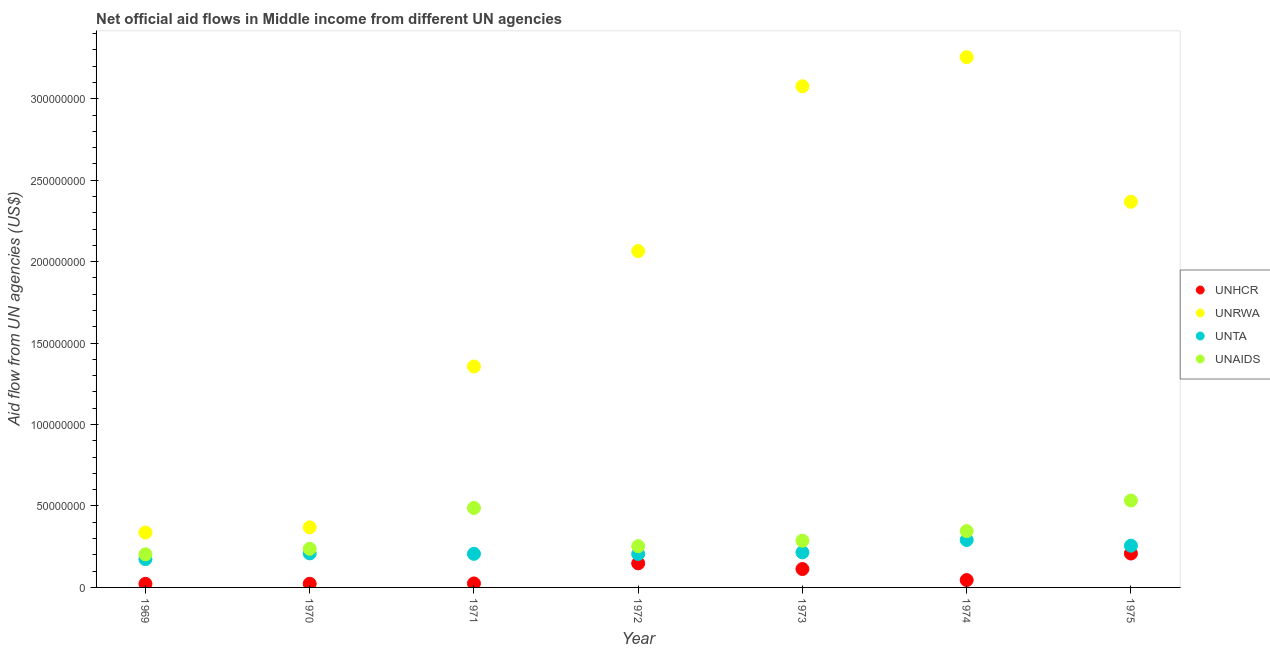What is the amount of aid given by unta in 1970?
Give a very brief answer. 2.09e+07. Across all years, what is the maximum amount of aid given by unrwa?
Your answer should be compact. 3.26e+08. Across all years, what is the minimum amount of aid given by unhcr?
Keep it short and to the point. 2.21e+06. In which year was the amount of aid given by unta maximum?
Keep it short and to the point. 1974. In which year was the amount of aid given by unaids minimum?
Keep it short and to the point. 1969. What is the total amount of aid given by unhcr in the graph?
Your answer should be very brief. 5.83e+07. What is the difference between the amount of aid given by unhcr in 1969 and that in 1970?
Keep it short and to the point. -3.00e+04. What is the difference between the amount of aid given by unaids in 1972 and the amount of aid given by unrwa in 1969?
Provide a short and direct response. -8.38e+06. What is the average amount of aid given by unhcr per year?
Your answer should be very brief. 8.33e+06. In the year 1970, what is the difference between the amount of aid given by unrwa and amount of aid given by unta?
Your answer should be compact. 1.60e+07. What is the ratio of the amount of aid given by unrwa in 1970 to that in 1972?
Your response must be concise. 0.18. What is the difference between the highest and the second highest amount of aid given by unrwa?
Give a very brief answer. 1.79e+07. What is the difference between the highest and the lowest amount of aid given by unta?
Make the answer very short. 1.18e+07. In how many years, is the amount of aid given by unta greater than the average amount of aid given by unta taken over all years?
Give a very brief answer. 2. Is the amount of aid given by unhcr strictly greater than the amount of aid given by unrwa over the years?
Keep it short and to the point. No. How many dotlines are there?
Offer a very short reply. 4. What is the difference between two consecutive major ticks on the Y-axis?
Your answer should be very brief. 5.00e+07. Are the values on the major ticks of Y-axis written in scientific E-notation?
Provide a short and direct response. No. Does the graph contain any zero values?
Ensure brevity in your answer.  No. Where does the legend appear in the graph?
Offer a very short reply. Center right. How are the legend labels stacked?
Your response must be concise. Vertical. What is the title of the graph?
Ensure brevity in your answer.  Net official aid flows in Middle income from different UN agencies. What is the label or title of the X-axis?
Ensure brevity in your answer.  Year. What is the label or title of the Y-axis?
Your answer should be very brief. Aid flow from UN agencies (US$). What is the Aid flow from UN agencies (US$) of UNHCR in 1969?
Your response must be concise. 2.21e+06. What is the Aid flow from UN agencies (US$) in UNRWA in 1969?
Offer a very short reply. 3.37e+07. What is the Aid flow from UN agencies (US$) of UNTA in 1969?
Provide a succinct answer. 1.74e+07. What is the Aid flow from UN agencies (US$) of UNAIDS in 1969?
Provide a short and direct response. 2.03e+07. What is the Aid flow from UN agencies (US$) in UNHCR in 1970?
Provide a succinct answer. 2.24e+06. What is the Aid flow from UN agencies (US$) of UNRWA in 1970?
Keep it short and to the point. 3.69e+07. What is the Aid flow from UN agencies (US$) of UNTA in 1970?
Your answer should be very brief. 2.09e+07. What is the Aid flow from UN agencies (US$) of UNAIDS in 1970?
Make the answer very short. 2.37e+07. What is the Aid flow from UN agencies (US$) of UNHCR in 1971?
Give a very brief answer. 2.44e+06. What is the Aid flow from UN agencies (US$) in UNRWA in 1971?
Keep it short and to the point. 1.36e+08. What is the Aid flow from UN agencies (US$) in UNTA in 1971?
Provide a succinct answer. 2.06e+07. What is the Aid flow from UN agencies (US$) of UNAIDS in 1971?
Your answer should be very brief. 4.88e+07. What is the Aid flow from UN agencies (US$) in UNHCR in 1972?
Provide a short and direct response. 1.48e+07. What is the Aid flow from UN agencies (US$) in UNRWA in 1972?
Offer a very short reply. 2.07e+08. What is the Aid flow from UN agencies (US$) in UNTA in 1972?
Your answer should be very brief. 2.05e+07. What is the Aid flow from UN agencies (US$) in UNAIDS in 1972?
Keep it short and to the point. 2.53e+07. What is the Aid flow from UN agencies (US$) of UNHCR in 1973?
Provide a succinct answer. 1.13e+07. What is the Aid flow from UN agencies (US$) of UNRWA in 1973?
Offer a terse response. 3.08e+08. What is the Aid flow from UN agencies (US$) in UNTA in 1973?
Give a very brief answer. 2.15e+07. What is the Aid flow from UN agencies (US$) in UNAIDS in 1973?
Ensure brevity in your answer.  2.87e+07. What is the Aid flow from UN agencies (US$) of UNHCR in 1974?
Make the answer very short. 4.51e+06. What is the Aid flow from UN agencies (US$) in UNRWA in 1974?
Your response must be concise. 3.26e+08. What is the Aid flow from UN agencies (US$) in UNTA in 1974?
Offer a very short reply. 2.91e+07. What is the Aid flow from UN agencies (US$) in UNAIDS in 1974?
Your answer should be compact. 3.46e+07. What is the Aid flow from UN agencies (US$) in UNHCR in 1975?
Offer a terse response. 2.08e+07. What is the Aid flow from UN agencies (US$) in UNRWA in 1975?
Your answer should be very brief. 2.37e+08. What is the Aid flow from UN agencies (US$) of UNTA in 1975?
Provide a succinct answer. 2.56e+07. What is the Aid flow from UN agencies (US$) in UNAIDS in 1975?
Offer a very short reply. 5.34e+07. Across all years, what is the maximum Aid flow from UN agencies (US$) of UNHCR?
Your response must be concise. 2.08e+07. Across all years, what is the maximum Aid flow from UN agencies (US$) in UNRWA?
Your answer should be very brief. 3.26e+08. Across all years, what is the maximum Aid flow from UN agencies (US$) in UNTA?
Your response must be concise. 2.91e+07. Across all years, what is the maximum Aid flow from UN agencies (US$) of UNAIDS?
Give a very brief answer. 5.34e+07. Across all years, what is the minimum Aid flow from UN agencies (US$) in UNHCR?
Provide a short and direct response. 2.21e+06. Across all years, what is the minimum Aid flow from UN agencies (US$) of UNRWA?
Provide a short and direct response. 3.37e+07. Across all years, what is the minimum Aid flow from UN agencies (US$) of UNTA?
Give a very brief answer. 1.74e+07. Across all years, what is the minimum Aid flow from UN agencies (US$) of UNAIDS?
Provide a succinct answer. 2.03e+07. What is the total Aid flow from UN agencies (US$) in UNHCR in the graph?
Provide a short and direct response. 5.83e+07. What is the total Aid flow from UN agencies (US$) in UNRWA in the graph?
Provide a succinct answer. 1.28e+09. What is the total Aid flow from UN agencies (US$) of UNTA in the graph?
Your answer should be very brief. 1.56e+08. What is the total Aid flow from UN agencies (US$) of UNAIDS in the graph?
Offer a very short reply. 2.35e+08. What is the difference between the Aid flow from UN agencies (US$) of UNHCR in 1969 and that in 1970?
Offer a terse response. -3.00e+04. What is the difference between the Aid flow from UN agencies (US$) of UNRWA in 1969 and that in 1970?
Ensure brevity in your answer.  -3.20e+06. What is the difference between the Aid flow from UN agencies (US$) in UNTA in 1969 and that in 1970?
Provide a short and direct response. -3.55e+06. What is the difference between the Aid flow from UN agencies (US$) in UNAIDS in 1969 and that in 1970?
Your response must be concise. -3.37e+06. What is the difference between the Aid flow from UN agencies (US$) of UNRWA in 1969 and that in 1971?
Give a very brief answer. -1.02e+08. What is the difference between the Aid flow from UN agencies (US$) of UNTA in 1969 and that in 1971?
Keep it short and to the point. -3.26e+06. What is the difference between the Aid flow from UN agencies (US$) in UNAIDS in 1969 and that in 1971?
Offer a terse response. -2.84e+07. What is the difference between the Aid flow from UN agencies (US$) of UNHCR in 1969 and that in 1972?
Give a very brief answer. -1.26e+07. What is the difference between the Aid flow from UN agencies (US$) of UNRWA in 1969 and that in 1972?
Keep it short and to the point. -1.73e+08. What is the difference between the Aid flow from UN agencies (US$) in UNTA in 1969 and that in 1972?
Ensure brevity in your answer.  -3.15e+06. What is the difference between the Aid flow from UN agencies (US$) of UNAIDS in 1969 and that in 1972?
Offer a very short reply. -4.99e+06. What is the difference between the Aid flow from UN agencies (US$) of UNHCR in 1969 and that in 1973?
Give a very brief answer. -9.09e+06. What is the difference between the Aid flow from UN agencies (US$) in UNRWA in 1969 and that in 1973?
Keep it short and to the point. -2.74e+08. What is the difference between the Aid flow from UN agencies (US$) of UNTA in 1969 and that in 1973?
Your answer should be very brief. -4.15e+06. What is the difference between the Aid flow from UN agencies (US$) in UNAIDS in 1969 and that in 1973?
Offer a terse response. -8.33e+06. What is the difference between the Aid flow from UN agencies (US$) in UNHCR in 1969 and that in 1974?
Ensure brevity in your answer.  -2.30e+06. What is the difference between the Aid flow from UN agencies (US$) of UNRWA in 1969 and that in 1974?
Your response must be concise. -2.92e+08. What is the difference between the Aid flow from UN agencies (US$) of UNTA in 1969 and that in 1974?
Provide a succinct answer. -1.18e+07. What is the difference between the Aid flow from UN agencies (US$) in UNAIDS in 1969 and that in 1974?
Your answer should be compact. -1.42e+07. What is the difference between the Aid flow from UN agencies (US$) in UNHCR in 1969 and that in 1975?
Your response must be concise. -1.86e+07. What is the difference between the Aid flow from UN agencies (US$) of UNRWA in 1969 and that in 1975?
Give a very brief answer. -2.03e+08. What is the difference between the Aid flow from UN agencies (US$) in UNTA in 1969 and that in 1975?
Your answer should be compact. -8.25e+06. What is the difference between the Aid flow from UN agencies (US$) of UNAIDS in 1969 and that in 1975?
Give a very brief answer. -3.30e+07. What is the difference between the Aid flow from UN agencies (US$) of UNRWA in 1970 and that in 1971?
Offer a very short reply. -9.87e+07. What is the difference between the Aid flow from UN agencies (US$) in UNTA in 1970 and that in 1971?
Provide a short and direct response. 2.90e+05. What is the difference between the Aid flow from UN agencies (US$) in UNAIDS in 1970 and that in 1971?
Offer a very short reply. -2.51e+07. What is the difference between the Aid flow from UN agencies (US$) in UNHCR in 1970 and that in 1972?
Make the answer very short. -1.26e+07. What is the difference between the Aid flow from UN agencies (US$) in UNRWA in 1970 and that in 1972?
Offer a very short reply. -1.70e+08. What is the difference between the Aid flow from UN agencies (US$) of UNTA in 1970 and that in 1972?
Make the answer very short. 4.00e+05. What is the difference between the Aid flow from UN agencies (US$) in UNAIDS in 1970 and that in 1972?
Keep it short and to the point. -1.62e+06. What is the difference between the Aid flow from UN agencies (US$) of UNHCR in 1970 and that in 1973?
Ensure brevity in your answer.  -9.06e+06. What is the difference between the Aid flow from UN agencies (US$) in UNRWA in 1970 and that in 1973?
Your answer should be very brief. -2.71e+08. What is the difference between the Aid flow from UN agencies (US$) in UNTA in 1970 and that in 1973?
Your response must be concise. -6.00e+05. What is the difference between the Aid flow from UN agencies (US$) in UNAIDS in 1970 and that in 1973?
Your response must be concise. -4.96e+06. What is the difference between the Aid flow from UN agencies (US$) in UNHCR in 1970 and that in 1974?
Offer a very short reply. -2.27e+06. What is the difference between the Aid flow from UN agencies (US$) in UNRWA in 1970 and that in 1974?
Ensure brevity in your answer.  -2.89e+08. What is the difference between the Aid flow from UN agencies (US$) in UNTA in 1970 and that in 1974?
Offer a terse response. -8.21e+06. What is the difference between the Aid flow from UN agencies (US$) in UNAIDS in 1970 and that in 1974?
Ensure brevity in your answer.  -1.09e+07. What is the difference between the Aid flow from UN agencies (US$) of UNHCR in 1970 and that in 1975?
Provide a succinct answer. -1.86e+07. What is the difference between the Aid flow from UN agencies (US$) of UNRWA in 1970 and that in 1975?
Your answer should be very brief. -2.00e+08. What is the difference between the Aid flow from UN agencies (US$) in UNTA in 1970 and that in 1975?
Offer a terse response. -4.70e+06. What is the difference between the Aid flow from UN agencies (US$) in UNAIDS in 1970 and that in 1975?
Keep it short and to the point. -2.97e+07. What is the difference between the Aid flow from UN agencies (US$) of UNHCR in 1971 and that in 1972?
Provide a short and direct response. -1.24e+07. What is the difference between the Aid flow from UN agencies (US$) in UNRWA in 1971 and that in 1972?
Offer a very short reply. -7.09e+07. What is the difference between the Aid flow from UN agencies (US$) in UNAIDS in 1971 and that in 1972?
Ensure brevity in your answer.  2.35e+07. What is the difference between the Aid flow from UN agencies (US$) of UNHCR in 1971 and that in 1973?
Provide a succinct answer. -8.86e+06. What is the difference between the Aid flow from UN agencies (US$) in UNRWA in 1971 and that in 1973?
Your response must be concise. -1.72e+08. What is the difference between the Aid flow from UN agencies (US$) of UNTA in 1971 and that in 1973?
Ensure brevity in your answer.  -8.90e+05. What is the difference between the Aid flow from UN agencies (US$) of UNAIDS in 1971 and that in 1973?
Your answer should be compact. 2.01e+07. What is the difference between the Aid flow from UN agencies (US$) in UNHCR in 1971 and that in 1974?
Ensure brevity in your answer.  -2.07e+06. What is the difference between the Aid flow from UN agencies (US$) in UNRWA in 1971 and that in 1974?
Provide a short and direct response. -1.90e+08. What is the difference between the Aid flow from UN agencies (US$) in UNTA in 1971 and that in 1974?
Provide a succinct answer. -8.50e+06. What is the difference between the Aid flow from UN agencies (US$) of UNAIDS in 1971 and that in 1974?
Provide a short and direct response. 1.42e+07. What is the difference between the Aid flow from UN agencies (US$) of UNHCR in 1971 and that in 1975?
Provide a short and direct response. -1.84e+07. What is the difference between the Aid flow from UN agencies (US$) of UNRWA in 1971 and that in 1975?
Offer a very short reply. -1.01e+08. What is the difference between the Aid flow from UN agencies (US$) in UNTA in 1971 and that in 1975?
Provide a succinct answer. -4.99e+06. What is the difference between the Aid flow from UN agencies (US$) in UNAIDS in 1971 and that in 1975?
Keep it short and to the point. -4.58e+06. What is the difference between the Aid flow from UN agencies (US$) of UNHCR in 1972 and that in 1973?
Keep it short and to the point. 3.49e+06. What is the difference between the Aid flow from UN agencies (US$) of UNRWA in 1972 and that in 1973?
Ensure brevity in your answer.  -1.01e+08. What is the difference between the Aid flow from UN agencies (US$) of UNTA in 1972 and that in 1973?
Your answer should be compact. -1.00e+06. What is the difference between the Aid flow from UN agencies (US$) in UNAIDS in 1972 and that in 1973?
Your response must be concise. -3.34e+06. What is the difference between the Aid flow from UN agencies (US$) of UNHCR in 1972 and that in 1974?
Your response must be concise. 1.03e+07. What is the difference between the Aid flow from UN agencies (US$) of UNRWA in 1972 and that in 1974?
Offer a terse response. -1.19e+08. What is the difference between the Aid flow from UN agencies (US$) in UNTA in 1972 and that in 1974?
Offer a very short reply. -8.61e+06. What is the difference between the Aid flow from UN agencies (US$) in UNAIDS in 1972 and that in 1974?
Offer a terse response. -9.25e+06. What is the difference between the Aid flow from UN agencies (US$) of UNHCR in 1972 and that in 1975?
Your answer should be very brief. -6.03e+06. What is the difference between the Aid flow from UN agencies (US$) of UNRWA in 1972 and that in 1975?
Give a very brief answer. -3.03e+07. What is the difference between the Aid flow from UN agencies (US$) in UNTA in 1972 and that in 1975?
Give a very brief answer. -5.10e+06. What is the difference between the Aid flow from UN agencies (US$) in UNAIDS in 1972 and that in 1975?
Provide a short and direct response. -2.80e+07. What is the difference between the Aid flow from UN agencies (US$) of UNHCR in 1973 and that in 1974?
Offer a very short reply. 6.79e+06. What is the difference between the Aid flow from UN agencies (US$) in UNRWA in 1973 and that in 1974?
Give a very brief answer. -1.79e+07. What is the difference between the Aid flow from UN agencies (US$) of UNTA in 1973 and that in 1974?
Give a very brief answer. -7.61e+06. What is the difference between the Aid flow from UN agencies (US$) of UNAIDS in 1973 and that in 1974?
Keep it short and to the point. -5.91e+06. What is the difference between the Aid flow from UN agencies (US$) of UNHCR in 1973 and that in 1975?
Offer a very short reply. -9.52e+06. What is the difference between the Aid flow from UN agencies (US$) of UNRWA in 1973 and that in 1975?
Provide a short and direct response. 7.09e+07. What is the difference between the Aid flow from UN agencies (US$) in UNTA in 1973 and that in 1975?
Your answer should be compact. -4.10e+06. What is the difference between the Aid flow from UN agencies (US$) in UNAIDS in 1973 and that in 1975?
Offer a very short reply. -2.47e+07. What is the difference between the Aid flow from UN agencies (US$) in UNHCR in 1974 and that in 1975?
Make the answer very short. -1.63e+07. What is the difference between the Aid flow from UN agencies (US$) of UNRWA in 1974 and that in 1975?
Make the answer very short. 8.88e+07. What is the difference between the Aid flow from UN agencies (US$) in UNTA in 1974 and that in 1975?
Keep it short and to the point. 3.51e+06. What is the difference between the Aid flow from UN agencies (US$) of UNAIDS in 1974 and that in 1975?
Keep it short and to the point. -1.88e+07. What is the difference between the Aid flow from UN agencies (US$) in UNHCR in 1969 and the Aid flow from UN agencies (US$) in UNRWA in 1970?
Your answer should be compact. -3.47e+07. What is the difference between the Aid flow from UN agencies (US$) in UNHCR in 1969 and the Aid flow from UN agencies (US$) in UNTA in 1970?
Give a very brief answer. -1.87e+07. What is the difference between the Aid flow from UN agencies (US$) in UNHCR in 1969 and the Aid flow from UN agencies (US$) in UNAIDS in 1970?
Make the answer very short. -2.15e+07. What is the difference between the Aid flow from UN agencies (US$) of UNRWA in 1969 and the Aid flow from UN agencies (US$) of UNTA in 1970?
Your response must be concise. 1.28e+07. What is the difference between the Aid flow from UN agencies (US$) in UNTA in 1969 and the Aid flow from UN agencies (US$) in UNAIDS in 1970?
Your answer should be very brief. -6.33e+06. What is the difference between the Aid flow from UN agencies (US$) of UNHCR in 1969 and the Aid flow from UN agencies (US$) of UNRWA in 1971?
Provide a succinct answer. -1.33e+08. What is the difference between the Aid flow from UN agencies (US$) in UNHCR in 1969 and the Aid flow from UN agencies (US$) in UNTA in 1971?
Your answer should be very brief. -1.84e+07. What is the difference between the Aid flow from UN agencies (US$) in UNHCR in 1969 and the Aid flow from UN agencies (US$) in UNAIDS in 1971?
Provide a succinct answer. -4.66e+07. What is the difference between the Aid flow from UN agencies (US$) in UNRWA in 1969 and the Aid flow from UN agencies (US$) in UNTA in 1971?
Your answer should be very brief. 1.31e+07. What is the difference between the Aid flow from UN agencies (US$) of UNRWA in 1969 and the Aid flow from UN agencies (US$) of UNAIDS in 1971?
Your response must be concise. -1.51e+07. What is the difference between the Aid flow from UN agencies (US$) in UNTA in 1969 and the Aid flow from UN agencies (US$) in UNAIDS in 1971?
Make the answer very short. -3.14e+07. What is the difference between the Aid flow from UN agencies (US$) in UNHCR in 1969 and the Aid flow from UN agencies (US$) in UNRWA in 1972?
Ensure brevity in your answer.  -2.04e+08. What is the difference between the Aid flow from UN agencies (US$) in UNHCR in 1969 and the Aid flow from UN agencies (US$) in UNTA in 1972?
Offer a very short reply. -1.83e+07. What is the difference between the Aid flow from UN agencies (US$) of UNHCR in 1969 and the Aid flow from UN agencies (US$) of UNAIDS in 1972?
Your answer should be very brief. -2.31e+07. What is the difference between the Aid flow from UN agencies (US$) of UNRWA in 1969 and the Aid flow from UN agencies (US$) of UNTA in 1972?
Your response must be concise. 1.32e+07. What is the difference between the Aid flow from UN agencies (US$) in UNRWA in 1969 and the Aid flow from UN agencies (US$) in UNAIDS in 1972?
Keep it short and to the point. 8.38e+06. What is the difference between the Aid flow from UN agencies (US$) in UNTA in 1969 and the Aid flow from UN agencies (US$) in UNAIDS in 1972?
Give a very brief answer. -7.95e+06. What is the difference between the Aid flow from UN agencies (US$) in UNHCR in 1969 and the Aid flow from UN agencies (US$) in UNRWA in 1973?
Offer a very short reply. -3.05e+08. What is the difference between the Aid flow from UN agencies (US$) of UNHCR in 1969 and the Aid flow from UN agencies (US$) of UNTA in 1973?
Offer a terse response. -1.93e+07. What is the difference between the Aid flow from UN agencies (US$) in UNHCR in 1969 and the Aid flow from UN agencies (US$) in UNAIDS in 1973?
Ensure brevity in your answer.  -2.64e+07. What is the difference between the Aid flow from UN agencies (US$) of UNRWA in 1969 and the Aid flow from UN agencies (US$) of UNTA in 1973?
Provide a short and direct response. 1.22e+07. What is the difference between the Aid flow from UN agencies (US$) of UNRWA in 1969 and the Aid flow from UN agencies (US$) of UNAIDS in 1973?
Offer a very short reply. 5.04e+06. What is the difference between the Aid flow from UN agencies (US$) of UNTA in 1969 and the Aid flow from UN agencies (US$) of UNAIDS in 1973?
Provide a short and direct response. -1.13e+07. What is the difference between the Aid flow from UN agencies (US$) in UNHCR in 1969 and the Aid flow from UN agencies (US$) in UNRWA in 1974?
Offer a terse response. -3.23e+08. What is the difference between the Aid flow from UN agencies (US$) in UNHCR in 1969 and the Aid flow from UN agencies (US$) in UNTA in 1974?
Make the answer very short. -2.69e+07. What is the difference between the Aid flow from UN agencies (US$) of UNHCR in 1969 and the Aid flow from UN agencies (US$) of UNAIDS in 1974?
Offer a terse response. -3.24e+07. What is the difference between the Aid flow from UN agencies (US$) in UNRWA in 1969 and the Aid flow from UN agencies (US$) in UNTA in 1974?
Make the answer very short. 4.57e+06. What is the difference between the Aid flow from UN agencies (US$) in UNRWA in 1969 and the Aid flow from UN agencies (US$) in UNAIDS in 1974?
Give a very brief answer. -8.70e+05. What is the difference between the Aid flow from UN agencies (US$) in UNTA in 1969 and the Aid flow from UN agencies (US$) in UNAIDS in 1974?
Ensure brevity in your answer.  -1.72e+07. What is the difference between the Aid flow from UN agencies (US$) of UNHCR in 1969 and the Aid flow from UN agencies (US$) of UNRWA in 1975?
Provide a short and direct response. -2.35e+08. What is the difference between the Aid flow from UN agencies (US$) in UNHCR in 1969 and the Aid flow from UN agencies (US$) in UNTA in 1975?
Make the answer very short. -2.34e+07. What is the difference between the Aid flow from UN agencies (US$) in UNHCR in 1969 and the Aid flow from UN agencies (US$) in UNAIDS in 1975?
Offer a very short reply. -5.12e+07. What is the difference between the Aid flow from UN agencies (US$) in UNRWA in 1969 and the Aid flow from UN agencies (US$) in UNTA in 1975?
Offer a terse response. 8.08e+06. What is the difference between the Aid flow from UN agencies (US$) of UNRWA in 1969 and the Aid flow from UN agencies (US$) of UNAIDS in 1975?
Your answer should be very brief. -1.97e+07. What is the difference between the Aid flow from UN agencies (US$) in UNTA in 1969 and the Aid flow from UN agencies (US$) in UNAIDS in 1975?
Your response must be concise. -3.60e+07. What is the difference between the Aid flow from UN agencies (US$) of UNHCR in 1970 and the Aid flow from UN agencies (US$) of UNRWA in 1971?
Ensure brevity in your answer.  -1.33e+08. What is the difference between the Aid flow from UN agencies (US$) of UNHCR in 1970 and the Aid flow from UN agencies (US$) of UNTA in 1971?
Your answer should be very brief. -1.84e+07. What is the difference between the Aid flow from UN agencies (US$) in UNHCR in 1970 and the Aid flow from UN agencies (US$) in UNAIDS in 1971?
Provide a succinct answer. -4.65e+07. What is the difference between the Aid flow from UN agencies (US$) in UNRWA in 1970 and the Aid flow from UN agencies (US$) in UNTA in 1971?
Give a very brief answer. 1.63e+07. What is the difference between the Aid flow from UN agencies (US$) of UNRWA in 1970 and the Aid flow from UN agencies (US$) of UNAIDS in 1971?
Offer a terse response. -1.19e+07. What is the difference between the Aid flow from UN agencies (US$) in UNTA in 1970 and the Aid flow from UN agencies (US$) in UNAIDS in 1971?
Keep it short and to the point. -2.79e+07. What is the difference between the Aid flow from UN agencies (US$) of UNHCR in 1970 and the Aid flow from UN agencies (US$) of UNRWA in 1972?
Provide a short and direct response. -2.04e+08. What is the difference between the Aid flow from UN agencies (US$) of UNHCR in 1970 and the Aid flow from UN agencies (US$) of UNTA in 1972?
Your answer should be very brief. -1.83e+07. What is the difference between the Aid flow from UN agencies (US$) in UNHCR in 1970 and the Aid flow from UN agencies (US$) in UNAIDS in 1972?
Your response must be concise. -2.31e+07. What is the difference between the Aid flow from UN agencies (US$) of UNRWA in 1970 and the Aid flow from UN agencies (US$) of UNTA in 1972?
Give a very brief answer. 1.64e+07. What is the difference between the Aid flow from UN agencies (US$) in UNRWA in 1970 and the Aid flow from UN agencies (US$) in UNAIDS in 1972?
Offer a terse response. 1.16e+07. What is the difference between the Aid flow from UN agencies (US$) of UNTA in 1970 and the Aid flow from UN agencies (US$) of UNAIDS in 1972?
Offer a terse response. -4.40e+06. What is the difference between the Aid flow from UN agencies (US$) of UNHCR in 1970 and the Aid flow from UN agencies (US$) of UNRWA in 1973?
Provide a succinct answer. -3.05e+08. What is the difference between the Aid flow from UN agencies (US$) in UNHCR in 1970 and the Aid flow from UN agencies (US$) in UNTA in 1973?
Provide a succinct answer. -1.93e+07. What is the difference between the Aid flow from UN agencies (US$) of UNHCR in 1970 and the Aid flow from UN agencies (US$) of UNAIDS in 1973?
Provide a short and direct response. -2.64e+07. What is the difference between the Aid flow from UN agencies (US$) of UNRWA in 1970 and the Aid flow from UN agencies (US$) of UNTA in 1973?
Your response must be concise. 1.54e+07. What is the difference between the Aid flow from UN agencies (US$) in UNRWA in 1970 and the Aid flow from UN agencies (US$) in UNAIDS in 1973?
Provide a short and direct response. 8.24e+06. What is the difference between the Aid flow from UN agencies (US$) in UNTA in 1970 and the Aid flow from UN agencies (US$) in UNAIDS in 1973?
Your response must be concise. -7.74e+06. What is the difference between the Aid flow from UN agencies (US$) of UNHCR in 1970 and the Aid flow from UN agencies (US$) of UNRWA in 1974?
Your answer should be very brief. -3.23e+08. What is the difference between the Aid flow from UN agencies (US$) in UNHCR in 1970 and the Aid flow from UN agencies (US$) in UNTA in 1974?
Ensure brevity in your answer.  -2.69e+07. What is the difference between the Aid flow from UN agencies (US$) of UNHCR in 1970 and the Aid flow from UN agencies (US$) of UNAIDS in 1974?
Ensure brevity in your answer.  -3.23e+07. What is the difference between the Aid flow from UN agencies (US$) of UNRWA in 1970 and the Aid flow from UN agencies (US$) of UNTA in 1974?
Keep it short and to the point. 7.77e+06. What is the difference between the Aid flow from UN agencies (US$) of UNRWA in 1970 and the Aid flow from UN agencies (US$) of UNAIDS in 1974?
Ensure brevity in your answer.  2.33e+06. What is the difference between the Aid flow from UN agencies (US$) of UNTA in 1970 and the Aid flow from UN agencies (US$) of UNAIDS in 1974?
Ensure brevity in your answer.  -1.36e+07. What is the difference between the Aid flow from UN agencies (US$) of UNHCR in 1970 and the Aid flow from UN agencies (US$) of UNRWA in 1975?
Offer a very short reply. -2.35e+08. What is the difference between the Aid flow from UN agencies (US$) in UNHCR in 1970 and the Aid flow from UN agencies (US$) in UNTA in 1975?
Your response must be concise. -2.34e+07. What is the difference between the Aid flow from UN agencies (US$) in UNHCR in 1970 and the Aid flow from UN agencies (US$) in UNAIDS in 1975?
Keep it short and to the point. -5.11e+07. What is the difference between the Aid flow from UN agencies (US$) of UNRWA in 1970 and the Aid flow from UN agencies (US$) of UNTA in 1975?
Your answer should be compact. 1.13e+07. What is the difference between the Aid flow from UN agencies (US$) of UNRWA in 1970 and the Aid flow from UN agencies (US$) of UNAIDS in 1975?
Give a very brief answer. -1.65e+07. What is the difference between the Aid flow from UN agencies (US$) in UNTA in 1970 and the Aid flow from UN agencies (US$) in UNAIDS in 1975?
Provide a succinct answer. -3.24e+07. What is the difference between the Aid flow from UN agencies (US$) in UNHCR in 1971 and the Aid flow from UN agencies (US$) in UNRWA in 1972?
Give a very brief answer. -2.04e+08. What is the difference between the Aid flow from UN agencies (US$) of UNHCR in 1971 and the Aid flow from UN agencies (US$) of UNTA in 1972?
Give a very brief answer. -1.81e+07. What is the difference between the Aid flow from UN agencies (US$) in UNHCR in 1971 and the Aid flow from UN agencies (US$) in UNAIDS in 1972?
Make the answer very short. -2.29e+07. What is the difference between the Aid flow from UN agencies (US$) of UNRWA in 1971 and the Aid flow from UN agencies (US$) of UNTA in 1972?
Provide a succinct answer. 1.15e+08. What is the difference between the Aid flow from UN agencies (US$) in UNRWA in 1971 and the Aid flow from UN agencies (US$) in UNAIDS in 1972?
Offer a terse response. 1.10e+08. What is the difference between the Aid flow from UN agencies (US$) of UNTA in 1971 and the Aid flow from UN agencies (US$) of UNAIDS in 1972?
Keep it short and to the point. -4.69e+06. What is the difference between the Aid flow from UN agencies (US$) of UNHCR in 1971 and the Aid flow from UN agencies (US$) of UNRWA in 1973?
Your response must be concise. -3.05e+08. What is the difference between the Aid flow from UN agencies (US$) in UNHCR in 1971 and the Aid flow from UN agencies (US$) in UNTA in 1973?
Your answer should be very brief. -1.91e+07. What is the difference between the Aid flow from UN agencies (US$) of UNHCR in 1971 and the Aid flow from UN agencies (US$) of UNAIDS in 1973?
Your response must be concise. -2.62e+07. What is the difference between the Aid flow from UN agencies (US$) in UNRWA in 1971 and the Aid flow from UN agencies (US$) in UNTA in 1973?
Your answer should be compact. 1.14e+08. What is the difference between the Aid flow from UN agencies (US$) of UNRWA in 1971 and the Aid flow from UN agencies (US$) of UNAIDS in 1973?
Your response must be concise. 1.07e+08. What is the difference between the Aid flow from UN agencies (US$) in UNTA in 1971 and the Aid flow from UN agencies (US$) in UNAIDS in 1973?
Offer a very short reply. -8.03e+06. What is the difference between the Aid flow from UN agencies (US$) in UNHCR in 1971 and the Aid flow from UN agencies (US$) in UNRWA in 1974?
Make the answer very short. -3.23e+08. What is the difference between the Aid flow from UN agencies (US$) in UNHCR in 1971 and the Aid flow from UN agencies (US$) in UNTA in 1974?
Give a very brief answer. -2.67e+07. What is the difference between the Aid flow from UN agencies (US$) of UNHCR in 1971 and the Aid flow from UN agencies (US$) of UNAIDS in 1974?
Make the answer very short. -3.21e+07. What is the difference between the Aid flow from UN agencies (US$) in UNRWA in 1971 and the Aid flow from UN agencies (US$) in UNTA in 1974?
Offer a terse response. 1.06e+08. What is the difference between the Aid flow from UN agencies (US$) in UNRWA in 1971 and the Aid flow from UN agencies (US$) in UNAIDS in 1974?
Your answer should be compact. 1.01e+08. What is the difference between the Aid flow from UN agencies (US$) of UNTA in 1971 and the Aid flow from UN agencies (US$) of UNAIDS in 1974?
Ensure brevity in your answer.  -1.39e+07. What is the difference between the Aid flow from UN agencies (US$) in UNHCR in 1971 and the Aid flow from UN agencies (US$) in UNRWA in 1975?
Keep it short and to the point. -2.34e+08. What is the difference between the Aid flow from UN agencies (US$) of UNHCR in 1971 and the Aid flow from UN agencies (US$) of UNTA in 1975?
Your answer should be very brief. -2.32e+07. What is the difference between the Aid flow from UN agencies (US$) of UNHCR in 1971 and the Aid flow from UN agencies (US$) of UNAIDS in 1975?
Offer a very short reply. -5.09e+07. What is the difference between the Aid flow from UN agencies (US$) in UNRWA in 1971 and the Aid flow from UN agencies (US$) in UNTA in 1975?
Keep it short and to the point. 1.10e+08. What is the difference between the Aid flow from UN agencies (US$) of UNRWA in 1971 and the Aid flow from UN agencies (US$) of UNAIDS in 1975?
Provide a succinct answer. 8.23e+07. What is the difference between the Aid flow from UN agencies (US$) in UNTA in 1971 and the Aid flow from UN agencies (US$) in UNAIDS in 1975?
Offer a terse response. -3.27e+07. What is the difference between the Aid flow from UN agencies (US$) of UNHCR in 1972 and the Aid flow from UN agencies (US$) of UNRWA in 1973?
Your answer should be very brief. -2.93e+08. What is the difference between the Aid flow from UN agencies (US$) in UNHCR in 1972 and the Aid flow from UN agencies (US$) in UNTA in 1973?
Your answer should be compact. -6.73e+06. What is the difference between the Aid flow from UN agencies (US$) of UNHCR in 1972 and the Aid flow from UN agencies (US$) of UNAIDS in 1973?
Keep it short and to the point. -1.39e+07. What is the difference between the Aid flow from UN agencies (US$) in UNRWA in 1972 and the Aid flow from UN agencies (US$) in UNTA in 1973?
Give a very brief answer. 1.85e+08. What is the difference between the Aid flow from UN agencies (US$) in UNRWA in 1972 and the Aid flow from UN agencies (US$) in UNAIDS in 1973?
Offer a terse response. 1.78e+08. What is the difference between the Aid flow from UN agencies (US$) in UNTA in 1972 and the Aid flow from UN agencies (US$) in UNAIDS in 1973?
Provide a succinct answer. -8.14e+06. What is the difference between the Aid flow from UN agencies (US$) in UNHCR in 1972 and the Aid flow from UN agencies (US$) in UNRWA in 1974?
Your answer should be very brief. -3.11e+08. What is the difference between the Aid flow from UN agencies (US$) of UNHCR in 1972 and the Aid flow from UN agencies (US$) of UNTA in 1974?
Make the answer very short. -1.43e+07. What is the difference between the Aid flow from UN agencies (US$) of UNHCR in 1972 and the Aid flow from UN agencies (US$) of UNAIDS in 1974?
Provide a short and direct response. -1.98e+07. What is the difference between the Aid flow from UN agencies (US$) in UNRWA in 1972 and the Aid flow from UN agencies (US$) in UNTA in 1974?
Offer a terse response. 1.77e+08. What is the difference between the Aid flow from UN agencies (US$) in UNRWA in 1972 and the Aid flow from UN agencies (US$) in UNAIDS in 1974?
Offer a very short reply. 1.72e+08. What is the difference between the Aid flow from UN agencies (US$) of UNTA in 1972 and the Aid flow from UN agencies (US$) of UNAIDS in 1974?
Give a very brief answer. -1.40e+07. What is the difference between the Aid flow from UN agencies (US$) in UNHCR in 1972 and the Aid flow from UN agencies (US$) in UNRWA in 1975?
Provide a short and direct response. -2.22e+08. What is the difference between the Aid flow from UN agencies (US$) in UNHCR in 1972 and the Aid flow from UN agencies (US$) in UNTA in 1975?
Offer a very short reply. -1.08e+07. What is the difference between the Aid flow from UN agencies (US$) of UNHCR in 1972 and the Aid flow from UN agencies (US$) of UNAIDS in 1975?
Your answer should be very brief. -3.86e+07. What is the difference between the Aid flow from UN agencies (US$) of UNRWA in 1972 and the Aid flow from UN agencies (US$) of UNTA in 1975?
Your answer should be compact. 1.81e+08. What is the difference between the Aid flow from UN agencies (US$) of UNRWA in 1972 and the Aid flow from UN agencies (US$) of UNAIDS in 1975?
Ensure brevity in your answer.  1.53e+08. What is the difference between the Aid flow from UN agencies (US$) in UNTA in 1972 and the Aid flow from UN agencies (US$) in UNAIDS in 1975?
Your answer should be very brief. -3.28e+07. What is the difference between the Aid flow from UN agencies (US$) in UNHCR in 1973 and the Aid flow from UN agencies (US$) in UNRWA in 1974?
Your response must be concise. -3.14e+08. What is the difference between the Aid flow from UN agencies (US$) in UNHCR in 1973 and the Aid flow from UN agencies (US$) in UNTA in 1974?
Provide a succinct answer. -1.78e+07. What is the difference between the Aid flow from UN agencies (US$) of UNHCR in 1973 and the Aid flow from UN agencies (US$) of UNAIDS in 1974?
Your answer should be compact. -2.33e+07. What is the difference between the Aid flow from UN agencies (US$) in UNRWA in 1973 and the Aid flow from UN agencies (US$) in UNTA in 1974?
Give a very brief answer. 2.79e+08. What is the difference between the Aid flow from UN agencies (US$) of UNRWA in 1973 and the Aid flow from UN agencies (US$) of UNAIDS in 1974?
Offer a very short reply. 2.73e+08. What is the difference between the Aid flow from UN agencies (US$) of UNTA in 1973 and the Aid flow from UN agencies (US$) of UNAIDS in 1974?
Keep it short and to the point. -1.30e+07. What is the difference between the Aid flow from UN agencies (US$) in UNHCR in 1973 and the Aid flow from UN agencies (US$) in UNRWA in 1975?
Offer a very short reply. -2.25e+08. What is the difference between the Aid flow from UN agencies (US$) in UNHCR in 1973 and the Aid flow from UN agencies (US$) in UNTA in 1975?
Ensure brevity in your answer.  -1.43e+07. What is the difference between the Aid flow from UN agencies (US$) in UNHCR in 1973 and the Aid flow from UN agencies (US$) in UNAIDS in 1975?
Give a very brief answer. -4.21e+07. What is the difference between the Aid flow from UN agencies (US$) in UNRWA in 1973 and the Aid flow from UN agencies (US$) in UNTA in 1975?
Make the answer very short. 2.82e+08. What is the difference between the Aid flow from UN agencies (US$) in UNRWA in 1973 and the Aid flow from UN agencies (US$) in UNAIDS in 1975?
Offer a very short reply. 2.54e+08. What is the difference between the Aid flow from UN agencies (US$) of UNTA in 1973 and the Aid flow from UN agencies (US$) of UNAIDS in 1975?
Ensure brevity in your answer.  -3.18e+07. What is the difference between the Aid flow from UN agencies (US$) in UNHCR in 1974 and the Aid flow from UN agencies (US$) in UNRWA in 1975?
Your answer should be very brief. -2.32e+08. What is the difference between the Aid flow from UN agencies (US$) of UNHCR in 1974 and the Aid flow from UN agencies (US$) of UNTA in 1975?
Keep it short and to the point. -2.11e+07. What is the difference between the Aid flow from UN agencies (US$) in UNHCR in 1974 and the Aid flow from UN agencies (US$) in UNAIDS in 1975?
Your answer should be compact. -4.88e+07. What is the difference between the Aid flow from UN agencies (US$) of UNRWA in 1974 and the Aid flow from UN agencies (US$) of UNTA in 1975?
Make the answer very short. 3.00e+08. What is the difference between the Aid flow from UN agencies (US$) of UNRWA in 1974 and the Aid flow from UN agencies (US$) of UNAIDS in 1975?
Your response must be concise. 2.72e+08. What is the difference between the Aid flow from UN agencies (US$) of UNTA in 1974 and the Aid flow from UN agencies (US$) of UNAIDS in 1975?
Provide a short and direct response. -2.42e+07. What is the average Aid flow from UN agencies (US$) in UNHCR per year?
Ensure brevity in your answer.  8.33e+06. What is the average Aid flow from UN agencies (US$) of UNRWA per year?
Keep it short and to the point. 1.83e+08. What is the average Aid flow from UN agencies (US$) in UNTA per year?
Provide a succinct answer. 2.22e+07. What is the average Aid flow from UN agencies (US$) of UNAIDS per year?
Ensure brevity in your answer.  3.35e+07. In the year 1969, what is the difference between the Aid flow from UN agencies (US$) of UNHCR and Aid flow from UN agencies (US$) of UNRWA?
Provide a short and direct response. -3.15e+07. In the year 1969, what is the difference between the Aid flow from UN agencies (US$) of UNHCR and Aid flow from UN agencies (US$) of UNTA?
Give a very brief answer. -1.52e+07. In the year 1969, what is the difference between the Aid flow from UN agencies (US$) in UNHCR and Aid flow from UN agencies (US$) in UNAIDS?
Your answer should be very brief. -1.81e+07. In the year 1969, what is the difference between the Aid flow from UN agencies (US$) in UNRWA and Aid flow from UN agencies (US$) in UNTA?
Give a very brief answer. 1.63e+07. In the year 1969, what is the difference between the Aid flow from UN agencies (US$) in UNRWA and Aid flow from UN agencies (US$) in UNAIDS?
Make the answer very short. 1.34e+07. In the year 1969, what is the difference between the Aid flow from UN agencies (US$) of UNTA and Aid flow from UN agencies (US$) of UNAIDS?
Offer a terse response. -2.96e+06. In the year 1970, what is the difference between the Aid flow from UN agencies (US$) in UNHCR and Aid flow from UN agencies (US$) in UNRWA?
Make the answer very short. -3.47e+07. In the year 1970, what is the difference between the Aid flow from UN agencies (US$) in UNHCR and Aid flow from UN agencies (US$) in UNTA?
Provide a short and direct response. -1.87e+07. In the year 1970, what is the difference between the Aid flow from UN agencies (US$) of UNHCR and Aid flow from UN agencies (US$) of UNAIDS?
Your answer should be very brief. -2.15e+07. In the year 1970, what is the difference between the Aid flow from UN agencies (US$) in UNRWA and Aid flow from UN agencies (US$) in UNTA?
Offer a terse response. 1.60e+07. In the year 1970, what is the difference between the Aid flow from UN agencies (US$) of UNRWA and Aid flow from UN agencies (US$) of UNAIDS?
Ensure brevity in your answer.  1.32e+07. In the year 1970, what is the difference between the Aid flow from UN agencies (US$) in UNTA and Aid flow from UN agencies (US$) in UNAIDS?
Keep it short and to the point. -2.78e+06. In the year 1971, what is the difference between the Aid flow from UN agencies (US$) of UNHCR and Aid flow from UN agencies (US$) of UNRWA?
Your response must be concise. -1.33e+08. In the year 1971, what is the difference between the Aid flow from UN agencies (US$) of UNHCR and Aid flow from UN agencies (US$) of UNTA?
Offer a very short reply. -1.82e+07. In the year 1971, what is the difference between the Aid flow from UN agencies (US$) of UNHCR and Aid flow from UN agencies (US$) of UNAIDS?
Ensure brevity in your answer.  -4.63e+07. In the year 1971, what is the difference between the Aid flow from UN agencies (US$) of UNRWA and Aid flow from UN agencies (US$) of UNTA?
Provide a short and direct response. 1.15e+08. In the year 1971, what is the difference between the Aid flow from UN agencies (US$) in UNRWA and Aid flow from UN agencies (US$) in UNAIDS?
Provide a short and direct response. 8.68e+07. In the year 1971, what is the difference between the Aid flow from UN agencies (US$) in UNTA and Aid flow from UN agencies (US$) in UNAIDS?
Provide a succinct answer. -2.82e+07. In the year 1972, what is the difference between the Aid flow from UN agencies (US$) in UNHCR and Aid flow from UN agencies (US$) in UNRWA?
Your answer should be very brief. -1.92e+08. In the year 1972, what is the difference between the Aid flow from UN agencies (US$) of UNHCR and Aid flow from UN agencies (US$) of UNTA?
Your response must be concise. -5.73e+06. In the year 1972, what is the difference between the Aid flow from UN agencies (US$) in UNHCR and Aid flow from UN agencies (US$) in UNAIDS?
Offer a terse response. -1.05e+07. In the year 1972, what is the difference between the Aid flow from UN agencies (US$) of UNRWA and Aid flow from UN agencies (US$) of UNTA?
Make the answer very short. 1.86e+08. In the year 1972, what is the difference between the Aid flow from UN agencies (US$) in UNRWA and Aid flow from UN agencies (US$) in UNAIDS?
Provide a short and direct response. 1.81e+08. In the year 1972, what is the difference between the Aid flow from UN agencies (US$) in UNTA and Aid flow from UN agencies (US$) in UNAIDS?
Provide a short and direct response. -4.80e+06. In the year 1973, what is the difference between the Aid flow from UN agencies (US$) in UNHCR and Aid flow from UN agencies (US$) in UNRWA?
Your response must be concise. -2.96e+08. In the year 1973, what is the difference between the Aid flow from UN agencies (US$) in UNHCR and Aid flow from UN agencies (US$) in UNTA?
Your answer should be compact. -1.02e+07. In the year 1973, what is the difference between the Aid flow from UN agencies (US$) of UNHCR and Aid flow from UN agencies (US$) of UNAIDS?
Provide a succinct answer. -1.74e+07. In the year 1973, what is the difference between the Aid flow from UN agencies (US$) in UNRWA and Aid flow from UN agencies (US$) in UNTA?
Offer a very short reply. 2.86e+08. In the year 1973, what is the difference between the Aid flow from UN agencies (US$) in UNRWA and Aid flow from UN agencies (US$) in UNAIDS?
Your response must be concise. 2.79e+08. In the year 1973, what is the difference between the Aid flow from UN agencies (US$) of UNTA and Aid flow from UN agencies (US$) of UNAIDS?
Make the answer very short. -7.14e+06. In the year 1974, what is the difference between the Aid flow from UN agencies (US$) of UNHCR and Aid flow from UN agencies (US$) of UNRWA?
Offer a terse response. -3.21e+08. In the year 1974, what is the difference between the Aid flow from UN agencies (US$) in UNHCR and Aid flow from UN agencies (US$) in UNTA?
Provide a short and direct response. -2.46e+07. In the year 1974, what is the difference between the Aid flow from UN agencies (US$) of UNHCR and Aid flow from UN agencies (US$) of UNAIDS?
Provide a short and direct response. -3.01e+07. In the year 1974, what is the difference between the Aid flow from UN agencies (US$) of UNRWA and Aid flow from UN agencies (US$) of UNTA?
Give a very brief answer. 2.96e+08. In the year 1974, what is the difference between the Aid flow from UN agencies (US$) of UNRWA and Aid flow from UN agencies (US$) of UNAIDS?
Your response must be concise. 2.91e+08. In the year 1974, what is the difference between the Aid flow from UN agencies (US$) in UNTA and Aid flow from UN agencies (US$) in UNAIDS?
Your response must be concise. -5.44e+06. In the year 1975, what is the difference between the Aid flow from UN agencies (US$) in UNHCR and Aid flow from UN agencies (US$) in UNRWA?
Your answer should be very brief. -2.16e+08. In the year 1975, what is the difference between the Aid flow from UN agencies (US$) of UNHCR and Aid flow from UN agencies (US$) of UNTA?
Keep it short and to the point. -4.80e+06. In the year 1975, what is the difference between the Aid flow from UN agencies (US$) of UNHCR and Aid flow from UN agencies (US$) of UNAIDS?
Your response must be concise. -3.25e+07. In the year 1975, what is the difference between the Aid flow from UN agencies (US$) in UNRWA and Aid flow from UN agencies (US$) in UNTA?
Your answer should be very brief. 2.11e+08. In the year 1975, what is the difference between the Aid flow from UN agencies (US$) of UNRWA and Aid flow from UN agencies (US$) of UNAIDS?
Make the answer very short. 1.83e+08. In the year 1975, what is the difference between the Aid flow from UN agencies (US$) of UNTA and Aid flow from UN agencies (US$) of UNAIDS?
Give a very brief answer. -2.77e+07. What is the ratio of the Aid flow from UN agencies (US$) of UNHCR in 1969 to that in 1970?
Offer a terse response. 0.99. What is the ratio of the Aid flow from UN agencies (US$) in UNRWA in 1969 to that in 1970?
Your answer should be compact. 0.91. What is the ratio of the Aid flow from UN agencies (US$) of UNTA in 1969 to that in 1970?
Your response must be concise. 0.83. What is the ratio of the Aid flow from UN agencies (US$) of UNAIDS in 1969 to that in 1970?
Offer a terse response. 0.86. What is the ratio of the Aid flow from UN agencies (US$) of UNHCR in 1969 to that in 1971?
Keep it short and to the point. 0.91. What is the ratio of the Aid flow from UN agencies (US$) in UNRWA in 1969 to that in 1971?
Ensure brevity in your answer.  0.25. What is the ratio of the Aid flow from UN agencies (US$) in UNTA in 1969 to that in 1971?
Your response must be concise. 0.84. What is the ratio of the Aid flow from UN agencies (US$) in UNAIDS in 1969 to that in 1971?
Provide a short and direct response. 0.42. What is the ratio of the Aid flow from UN agencies (US$) in UNHCR in 1969 to that in 1972?
Keep it short and to the point. 0.15. What is the ratio of the Aid flow from UN agencies (US$) in UNRWA in 1969 to that in 1972?
Your response must be concise. 0.16. What is the ratio of the Aid flow from UN agencies (US$) in UNTA in 1969 to that in 1972?
Your response must be concise. 0.85. What is the ratio of the Aid flow from UN agencies (US$) in UNAIDS in 1969 to that in 1972?
Your answer should be very brief. 0.8. What is the ratio of the Aid flow from UN agencies (US$) of UNHCR in 1969 to that in 1973?
Your answer should be very brief. 0.2. What is the ratio of the Aid flow from UN agencies (US$) of UNRWA in 1969 to that in 1973?
Your answer should be compact. 0.11. What is the ratio of the Aid flow from UN agencies (US$) of UNTA in 1969 to that in 1973?
Your answer should be very brief. 0.81. What is the ratio of the Aid flow from UN agencies (US$) of UNAIDS in 1969 to that in 1973?
Give a very brief answer. 0.71. What is the ratio of the Aid flow from UN agencies (US$) of UNHCR in 1969 to that in 1974?
Provide a short and direct response. 0.49. What is the ratio of the Aid flow from UN agencies (US$) in UNRWA in 1969 to that in 1974?
Offer a very short reply. 0.1. What is the ratio of the Aid flow from UN agencies (US$) of UNTA in 1969 to that in 1974?
Ensure brevity in your answer.  0.6. What is the ratio of the Aid flow from UN agencies (US$) of UNAIDS in 1969 to that in 1974?
Provide a short and direct response. 0.59. What is the ratio of the Aid flow from UN agencies (US$) in UNHCR in 1969 to that in 1975?
Keep it short and to the point. 0.11. What is the ratio of the Aid flow from UN agencies (US$) of UNRWA in 1969 to that in 1975?
Your answer should be very brief. 0.14. What is the ratio of the Aid flow from UN agencies (US$) of UNTA in 1969 to that in 1975?
Your answer should be very brief. 0.68. What is the ratio of the Aid flow from UN agencies (US$) in UNAIDS in 1969 to that in 1975?
Provide a succinct answer. 0.38. What is the ratio of the Aid flow from UN agencies (US$) in UNHCR in 1970 to that in 1971?
Your response must be concise. 0.92. What is the ratio of the Aid flow from UN agencies (US$) in UNRWA in 1970 to that in 1971?
Your answer should be very brief. 0.27. What is the ratio of the Aid flow from UN agencies (US$) of UNTA in 1970 to that in 1971?
Your answer should be very brief. 1.01. What is the ratio of the Aid flow from UN agencies (US$) in UNAIDS in 1970 to that in 1971?
Provide a short and direct response. 0.49. What is the ratio of the Aid flow from UN agencies (US$) of UNHCR in 1970 to that in 1972?
Keep it short and to the point. 0.15. What is the ratio of the Aid flow from UN agencies (US$) in UNRWA in 1970 to that in 1972?
Your answer should be very brief. 0.18. What is the ratio of the Aid flow from UN agencies (US$) of UNTA in 1970 to that in 1972?
Offer a terse response. 1.02. What is the ratio of the Aid flow from UN agencies (US$) in UNAIDS in 1970 to that in 1972?
Your answer should be very brief. 0.94. What is the ratio of the Aid flow from UN agencies (US$) of UNHCR in 1970 to that in 1973?
Provide a succinct answer. 0.2. What is the ratio of the Aid flow from UN agencies (US$) of UNRWA in 1970 to that in 1973?
Provide a succinct answer. 0.12. What is the ratio of the Aid flow from UN agencies (US$) of UNTA in 1970 to that in 1973?
Provide a short and direct response. 0.97. What is the ratio of the Aid flow from UN agencies (US$) of UNAIDS in 1970 to that in 1973?
Keep it short and to the point. 0.83. What is the ratio of the Aid flow from UN agencies (US$) in UNHCR in 1970 to that in 1974?
Offer a terse response. 0.5. What is the ratio of the Aid flow from UN agencies (US$) of UNRWA in 1970 to that in 1974?
Provide a short and direct response. 0.11. What is the ratio of the Aid flow from UN agencies (US$) in UNTA in 1970 to that in 1974?
Offer a very short reply. 0.72. What is the ratio of the Aid flow from UN agencies (US$) of UNAIDS in 1970 to that in 1974?
Provide a succinct answer. 0.69. What is the ratio of the Aid flow from UN agencies (US$) in UNHCR in 1970 to that in 1975?
Keep it short and to the point. 0.11. What is the ratio of the Aid flow from UN agencies (US$) of UNRWA in 1970 to that in 1975?
Keep it short and to the point. 0.16. What is the ratio of the Aid flow from UN agencies (US$) in UNTA in 1970 to that in 1975?
Keep it short and to the point. 0.82. What is the ratio of the Aid flow from UN agencies (US$) in UNAIDS in 1970 to that in 1975?
Give a very brief answer. 0.44. What is the ratio of the Aid flow from UN agencies (US$) of UNHCR in 1971 to that in 1972?
Ensure brevity in your answer.  0.17. What is the ratio of the Aid flow from UN agencies (US$) of UNRWA in 1971 to that in 1972?
Give a very brief answer. 0.66. What is the ratio of the Aid flow from UN agencies (US$) in UNTA in 1971 to that in 1972?
Give a very brief answer. 1.01. What is the ratio of the Aid flow from UN agencies (US$) of UNAIDS in 1971 to that in 1972?
Your answer should be compact. 1.93. What is the ratio of the Aid flow from UN agencies (US$) in UNHCR in 1971 to that in 1973?
Offer a terse response. 0.22. What is the ratio of the Aid flow from UN agencies (US$) in UNRWA in 1971 to that in 1973?
Provide a succinct answer. 0.44. What is the ratio of the Aid flow from UN agencies (US$) in UNTA in 1971 to that in 1973?
Offer a terse response. 0.96. What is the ratio of the Aid flow from UN agencies (US$) in UNAIDS in 1971 to that in 1973?
Make the answer very short. 1.7. What is the ratio of the Aid flow from UN agencies (US$) in UNHCR in 1971 to that in 1974?
Your answer should be compact. 0.54. What is the ratio of the Aid flow from UN agencies (US$) of UNRWA in 1971 to that in 1974?
Ensure brevity in your answer.  0.42. What is the ratio of the Aid flow from UN agencies (US$) of UNTA in 1971 to that in 1974?
Make the answer very short. 0.71. What is the ratio of the Aid flow from UN agencies (US$) of UNAIDS in 1971 to that in 1974?
Offer a terse response. 1.41. What is the ratio of the Aid flow from UN agencies (US$) in UNHCR in 1971 to that in 1975?
Make the answer very short. 0.12. What is the ratio of the Aid flow from UN agencies (US$) of UNRWA in 1971 to that in 1975?
Ensure brevity in your answer.  0.57. What is the ratio of the Aid flow from UN agencies (US$) of UNTA in 1971 to that in 1975?
Your answer should be compact. 0.81. What is the ratio of the Aid flow from UN agencies (US$) in UNAIDS in 1971 to that in 1975?
Ensure brevity in your answer.  0.91. What is the ratio of the Aid flow from UN agencies (US$) in UNHCR in 1972 to that in 1973?
Provide a succinct answer. 1.31. What is the ratio of the Aid flow from UN agencies (US$) in UNRWA in 1972 to that in 1973?
Keep it short and to the point. 0.67. What is the ratio of the Aid flow from UN agencies (US$) in UNTA in 1972 to that in 1973?
Make the answer very short. 0.95. What is the ratio of the Aid flow from UN agencies (US$) of UNAIDS in 1972 to that in 1973?
Keep it short and to the point. 0.88. What is the ratio of the Aid flow from UN agencies (US$) of UNHCR in 1972 to that in 1974?
Your answer should be compact. 3.28. What is the ratio of the Aid flow from UN agencies (US$) of UNRWA in 1972 to that in 1974?
Make the answer very short. 0.63. What is the ratio of the Aid flow from UN agencies (US$) in UNTA in 1972 to that in 1974?
Offer a terse response. 0.7. What is the ratio of the Aid flow from UN agencies (US$) of UNAIDS in 1972 to that in 1974?
Provide a short and direct response. 0.73. What is the ratio of the Aid flow from UN agencies (US$) of UNHCR in 1972 to that in 1975?
Provide a short and direct response. 0.71. What is the ratio of the Aid flow from UN agencies (US$) in UNRWA in 1972 to that in 1975?
Make the answer very short. 0.87. What is the ratio of the Aid flow from UN agencies (US$) in UNTA in 1972 to that in 1975?
Provide a succinct answer. 0.8. What is the ratio of the Aid flow from UN agencies (US$) of UNAIDS in 1972 to that in 1975?
Your answer should be very brief. 0.47. What is the ratio of the Aid flow from UN agencies (US$) in UNHCR in 1973 to that in 1974?
Ensure brevity in your answer.  2.51. What is the ratio of the Aid flow from UN agencies (US$) in UNRWA in 1973 to that in 1974?
Provide a short and direct response. 0.95. What is the ratio of the Aid flow from UN agencies (US$) in UNTA in 1973 to that in 1974?
Your answer should be compact. 0.74. What is the ratio of the Aid flow from UN agencies (US$) in UNAIDS in 1973 to that in 1974?
Ensure brevity in your answer.  0.83. What is the ratio of the Aid flow from UN agencies (US$) of UNHCR in 1973 to that in 1975?
Provide a short and direct response. 0.54. What is the ratio of the Aid flow from UN agencies (US$) in UNRWA in 1973 to that in 1975?
Offer a very short reply. 1.3. What is the ratio of the Aid flow from UN agencies (US$) in UNTA in 1973 to that in 1975?
Make the answer very short. 0.84. What is the ratio of the Aid flow from UN agencies (US$) of UNAIDS in 1973 to that in 1975?
Give a very brief answer. 0.54. What is the ratio of the Aid flow from UN agencies (US$) in UNHCR in 1974 to that in 1975?
Your answer should be compact. 0.22. What is the ratio of the Aid flow from UN agencies (US$) in UNRWA in 1974 to that in 1975?
Offer a very short reply. 1.38. What is the ratio of the Aid flow from UN agencies (US$) in UNTA in 1974 to that in 1975?
Your answer should be compact. 1.14. What is the ratio of the Aid flow from UN agencies (US$) of UNAIDS in 1974 to that in 1975?
Provide a short and direct response. 0.65. What is the difference between the highest and the second highest Aid flow from UN agencies (US$) of UNHCR?
Offer a terse response. 6.03e+06. What is the difference between the highest and the second highest Aid flow from UN agencies (US$) in UNRWA?
Give a very brief answer. 1.79e+07. What is the difference between the highest and the second highest Aid flow from UN agencies (US$) of UNTA?
Provide a short and direct response. 3.51e+06. What is the difference between the highest and the second highest Aid flow from UN agencies (US$) in UNAIDS?
Provide a short and direct response. 4.58e+06. What is the difference between the highest and the lowest Aid flow from UN agencies (US$) in UNHCR?
Your answer should be compact. 1.86e+07. What is the difference between the highest and the lowest Aid flow from UN agencies (US$) of UNRWA?
Your answer should be very brief. 2.92e+08. What is the difference between the highest and the lowest Aid flow from UN agencies (US$) in UNTA?
Provide a short and direct response. 1.18e+07. What is the difference between the highest and the lowest Aid flow from UN agencies (US$) of UNAIDS?
Make the answer very short. 3.30e+07. 